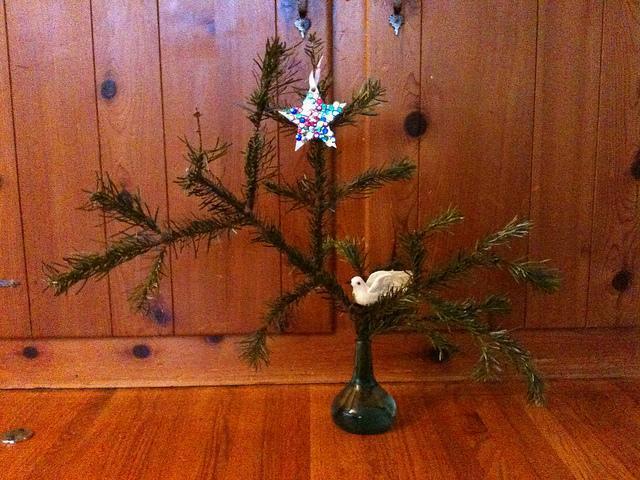How many giraffes can you see?
Give a very brief answer. 0. 